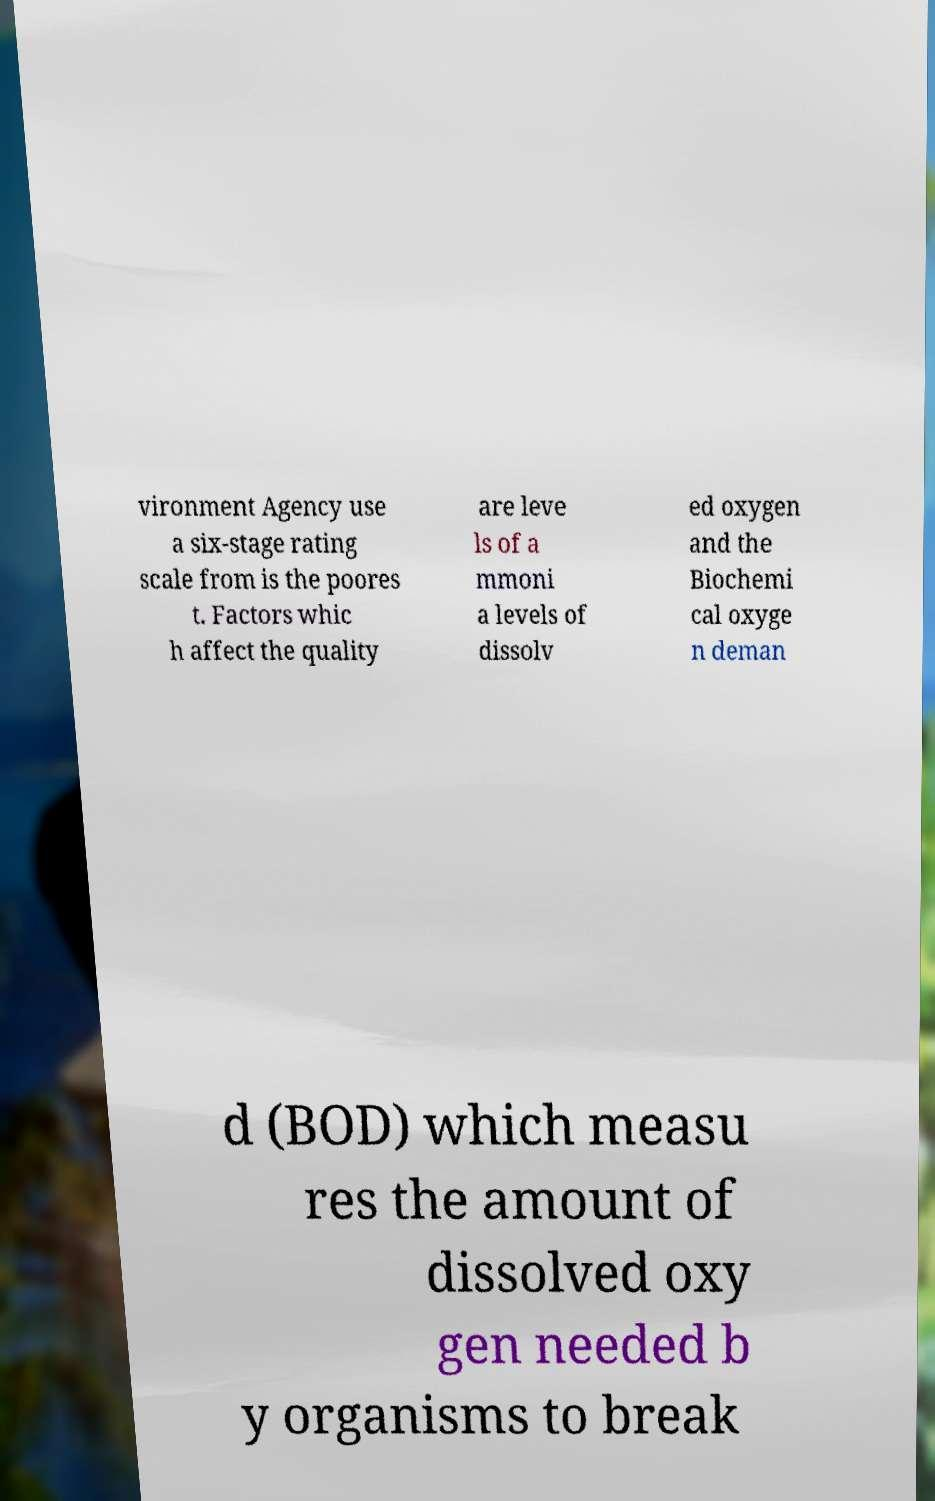Could you extract and type out the text from this image? vironment Agency use a six-stage rating scale from is the poores t. Factors whic h affect the quality are leve ls of a mmoni a levels of dissolv ed oxygen and the Biochemi cal oxyge n deman d (BOD) which measu res the amount of dissolved oxy gen needed b y organisms to break 